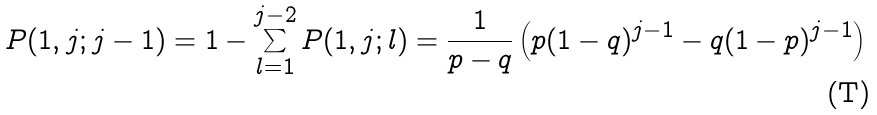Convert formula to latex. <formula><loc_0><loc_0><loc_500><loc_500>P ( 1 , j ; j - 1 ) = 1 - \sum _ { l = 1 } ^ { j - 2 } P ( 1 , j ; l ) = \frac { 1 } { p - q } \left ( p ( 1 - q ) ^ { j - 1 } - q ( 1 - p ) ^ { j - 1 } \right )</formula> 